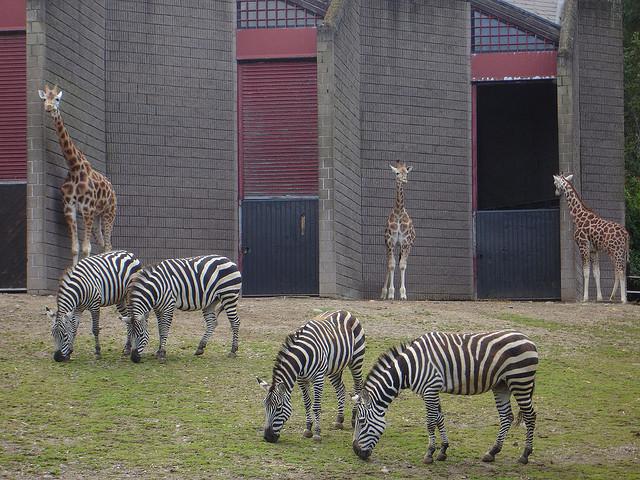How many creatures are in the photo?
Short answer required. 7. What kind of animals?
Short answer required. Zebras, giraffes. Is these animal real or photoshop?
Write a very short answer. Real. Which zebra is younger?
Keep it brief. Middle. Are any of the animals looking at each other?
Keep it brief. No. Is the land sparsely furnished?
Answer briefly. Yes. How many zebras?
Quick response, please. 4. How many types of animals are there?
Quick response, please. 2. What animal is in this pic?
Answer briefly. Zebra. Is the giraffe's head visible in this photo?
Answer briefly. Yes. Are the zebras indoors?
Give a very brief answer. No. Are these zebras babies?
Be succinct. No. What are these animals called?
Short answer required. Zebras and giraffes. What shape is the building in the background?
Keep it brief. Rectangle. What are the giant walls near the giraffe for?
Keep it brief. Building. What color is the ground in the pen?
Be succinct. Green. Is the picture colored?
Answer briefly. Yes. What animals are pictured?
Short answer required. Zebras. Can the giraffes eat the same thing the zebras are eating?
Quick response, please. Yes. How many species of animals are there?
Write a very short answer. 2. Is there an animal beside the giraffe?
Quick response, please. Yes. What are the animals?
Be succinct. Zebras and giraffes. 